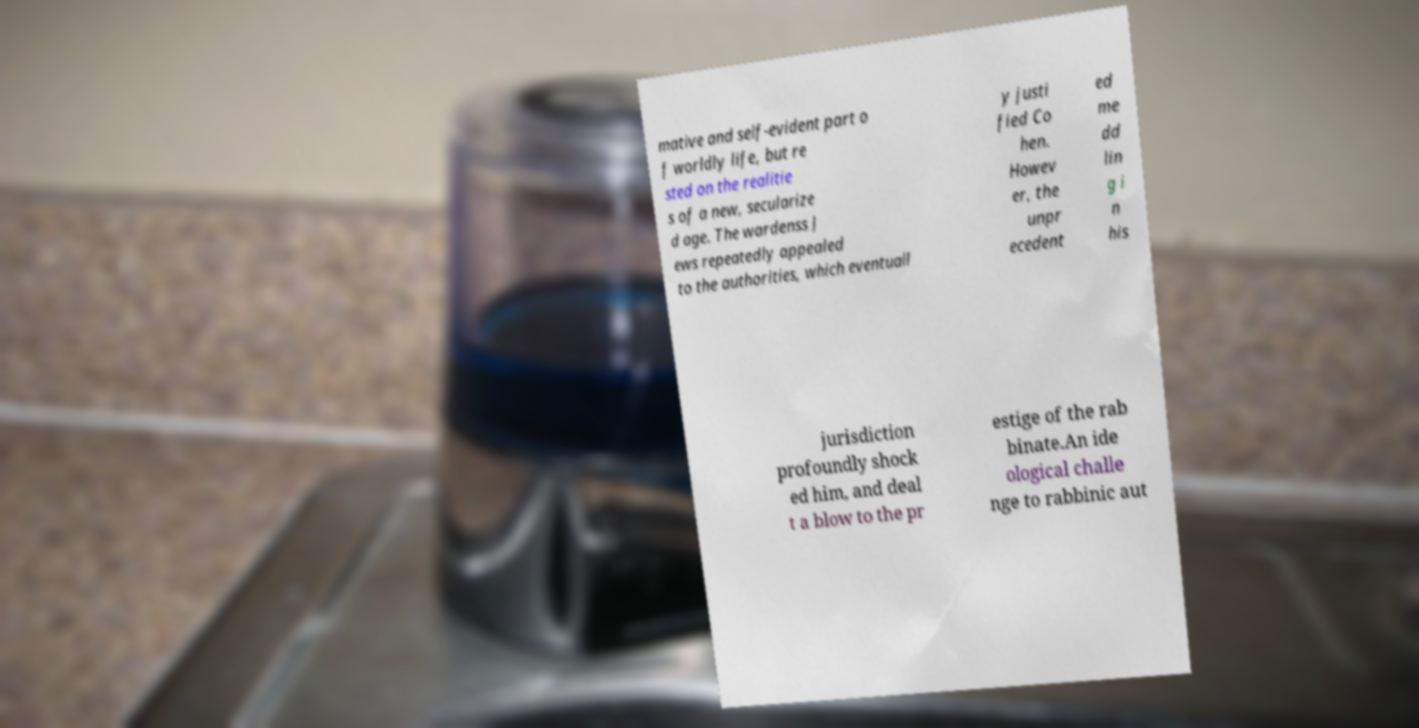Please identify and transcribe the text found in this image. mative and self-evident part o f worldly life, but re sted on the realitie s of a new, secularize d age. The wardenss J ews repeatedly appealed to the authorities, which eventuall y justi fied Co hen. Howev er, the unpr ecedent ed me dd lin g i n his jurisdiction profoundly shock ed him, and deal t a blow to the pr estige of the rab binate.An ide ological challe nge to rabbinic aut 